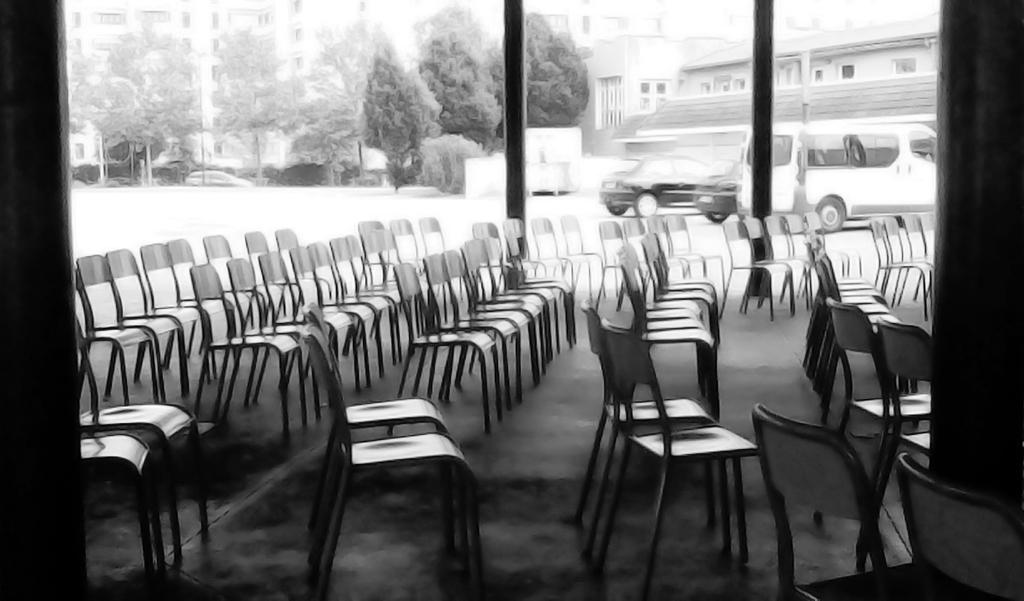What is the color scheme of the image? The image is black and white. What objects are present in large numbers in the image? There are many chairs in the image. What can be seen in the background of the image? There are vehicles in the background of the image. What type of structures are visible in the image? There are buildings with windows in the image. What type of vegetation is present in the image? There are trees in the image. What type of ship can be seen sailing in the image? There is no ship present in the image; it is a black and white image featuring many chairs, vehicles in the background, buildings with windows, and trees. 